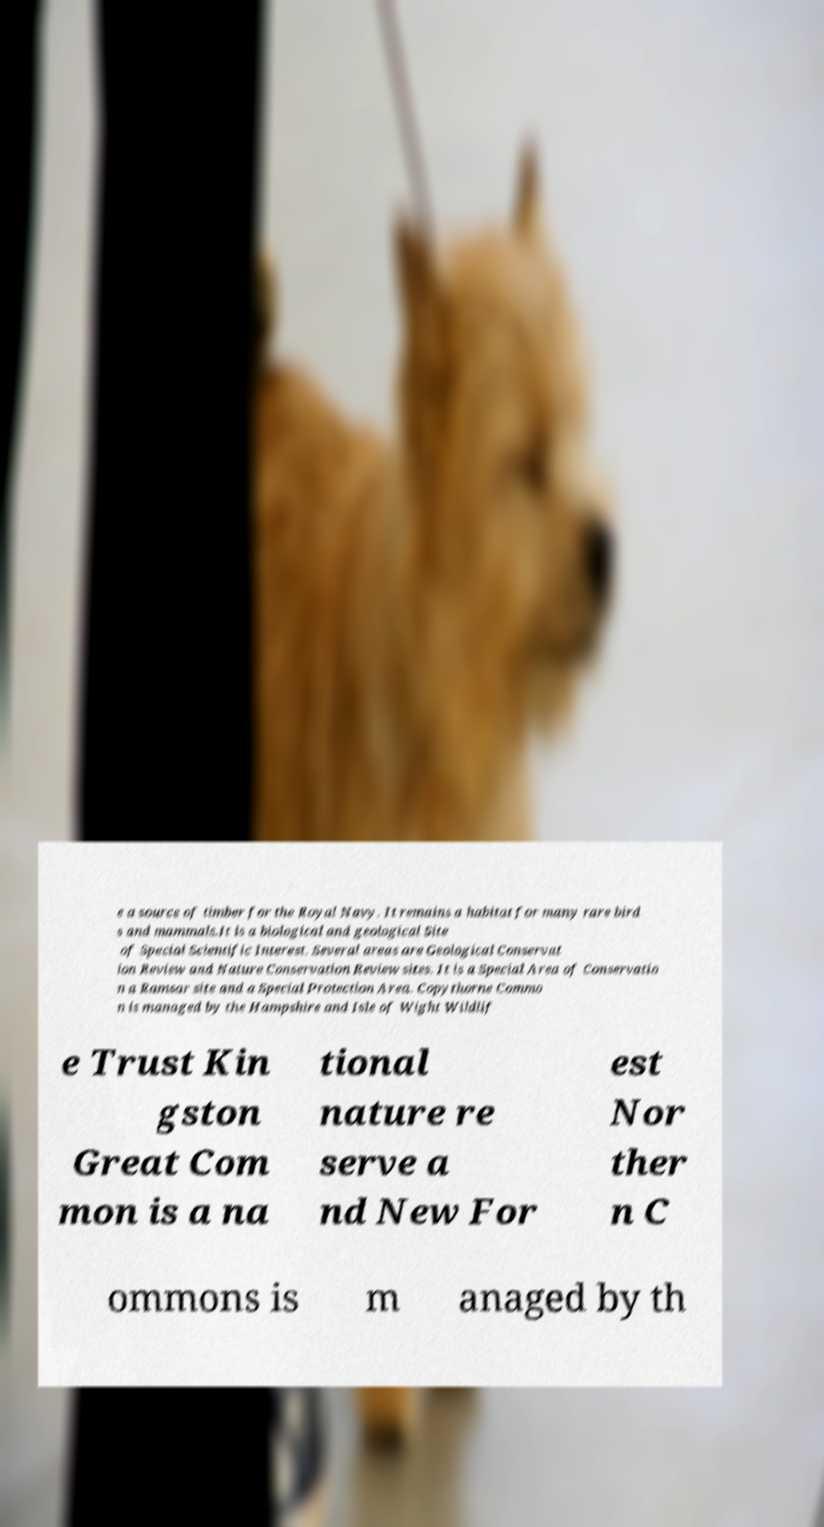Could you assist in decoding the text presented in this image and type it out clearly? e a source of timber for the Royal Navy. It remains a habitat for many rare bird s and mammals.It is a biological and geological Site of Special Scientific Interest. Several areas are Geological Conservat ion Review and Nature Conservation Review sites. It is a Special Area of Conservatio n a Ramsar site and a Special Protection Area. Copythorne Commo n is managed by the Hampshire and Isle of Wight Wildlif e Trust Kin gston Great Com mon is a na tional nature re serve a nd New For est Nor ther n C ommons is m anaged by th 